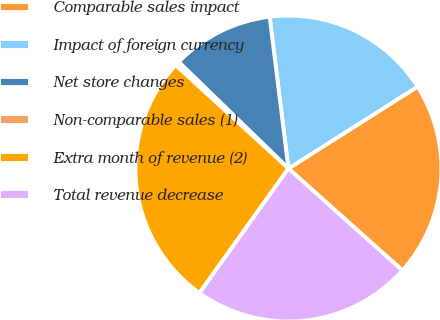Convert chart to OTSL. <chart><loc_0><loc_0><loc_500><loc_500><pie_chart><fcel>Comparable sales impact<fcel>Impact of foreign currency<fcel>Net store changes<fcel>Non-comparable sales (1)<fcel>Extra month of revenue (2)<fcel>Total revenue decrease<nl><fcel>20.61%<fcel>17.96%<fcel>10.78%<fcel>0.45%<fcel>26.94%<fcel>23.26%<nl></chart> 